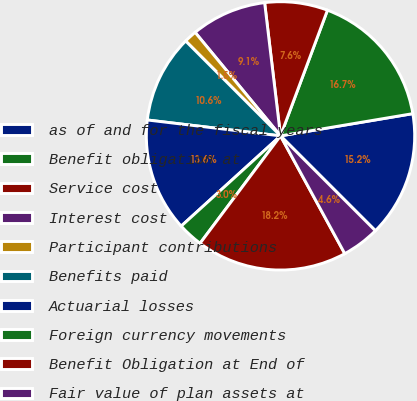Convert chart to OTSL. <chart><loc_0><loc_0><loc_500><loc_500><pie_chart><fcel>as of and for the fiscal years<fcel>Benefit obligation at<fcel>Service cost<fcel>Interest cost<fcel>Participant contributions<fcel>Benefits paid<fcel>Actuarial losses<fcel>Foreign currency movements<fcel>Benefit Obligation at End of<fcel>Fair value of plan assets at<nl><fcel>15.15%<fcel>16.66%<fcel>7.58%<fcel>9.09%<fcel>1.52%<fcel>10.61%<fcel>13.63%<fcel>3.03%<fcel>18.18%<fcel>4.55%<nl></chart> 